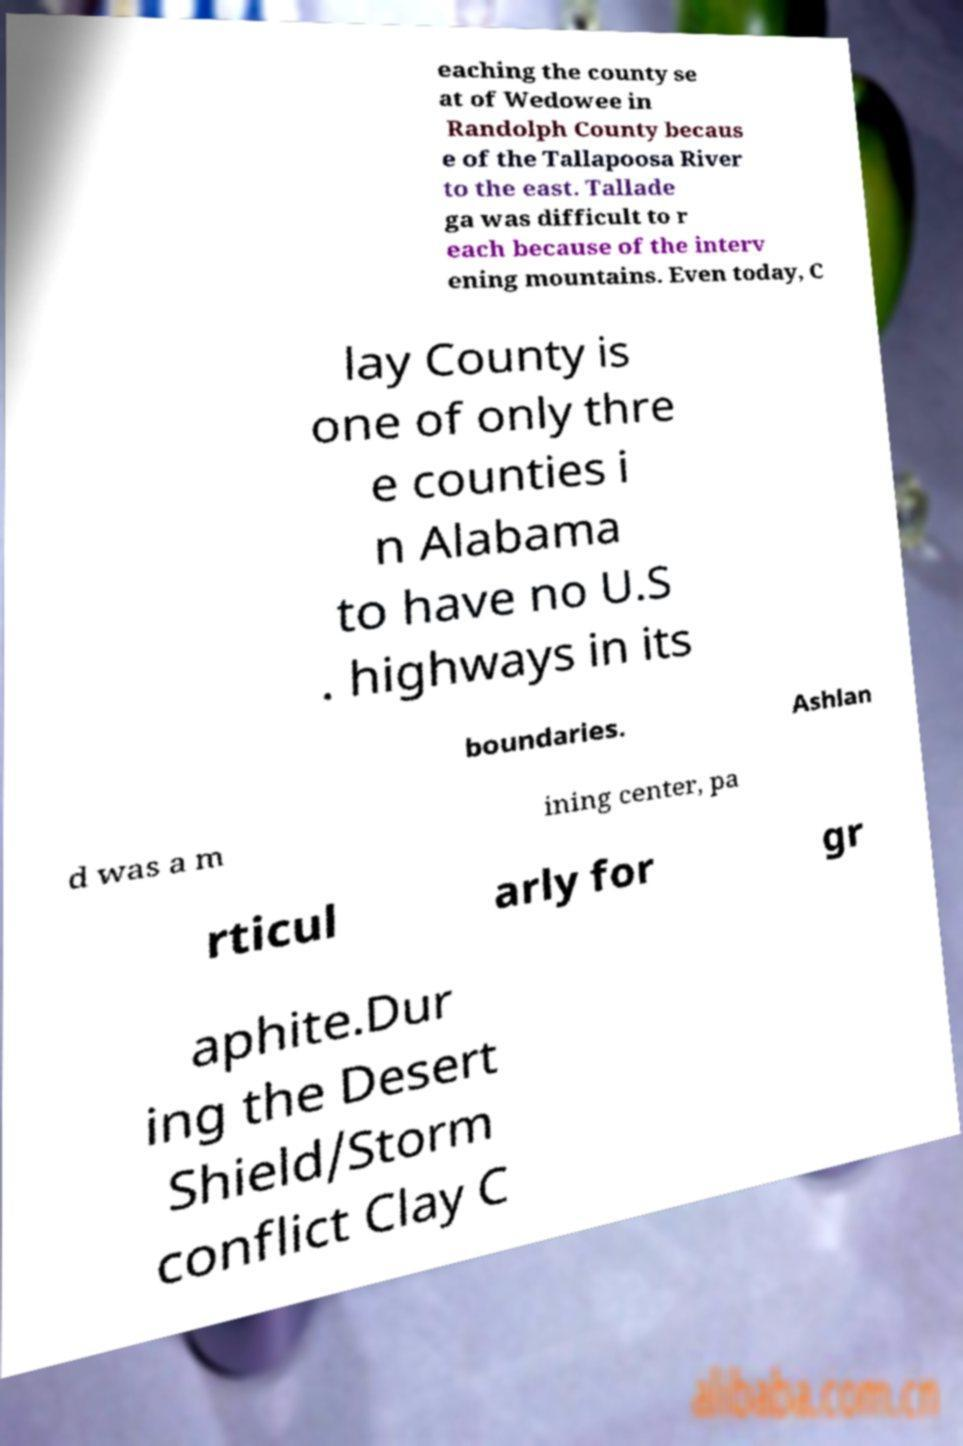What messages or text are displayed in this image? I need them in a readable, typed format. eaching the county se at of Wedowee in Randolph County becaus e of the Tallapoosa River to the east. Tallade ga was difficult to r each because of the interv ening mountains. Even today, C lay County is one of only thre e counties i n Alabama to have no U.S . highways in its boundaries. Ashlan d was a m ining center, pa rticul arly for gr aphite.Dur ing the Desert Shield/Storm conflict Clay C 